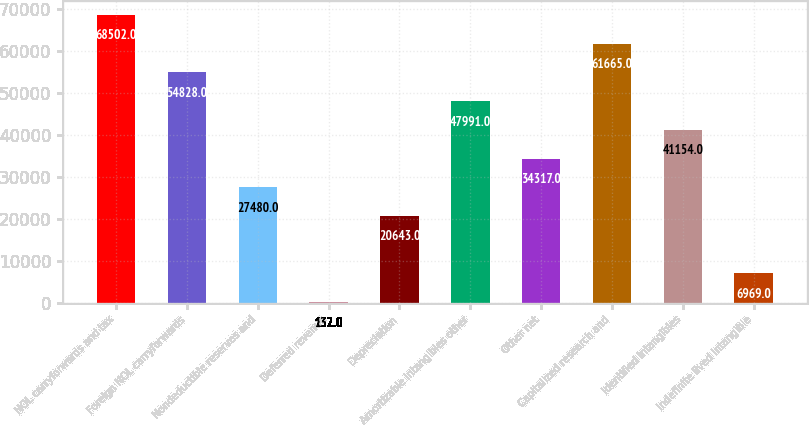Convert chart to OTSL. <chart><loc_0><loc_0><loc_500><loc_500><bar_chart><fcel>NOL carryforwards and tax<fcel>Foreign NOL carryforwards<fcel>Nondeductible reserves and<fcel>Deferred revenue<fcel>Depreciation<fcel>Amortizable intangibles other<fcel>Other net<fcel>Capitalized research and<fcel>Identified intangibles<fcel>Indefinite lived intangible<nl><fcel>68502<fcel>54828<fcel>27480<fcel>132<fcel>20643<fcel>47991<fcel>34317<fcel>61665<fcel>41154<fcel>6969<nl></chart> 